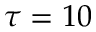<formula> <loc_0><loc_0><loc_500><loc_500>\tau = 1 0</formula> 